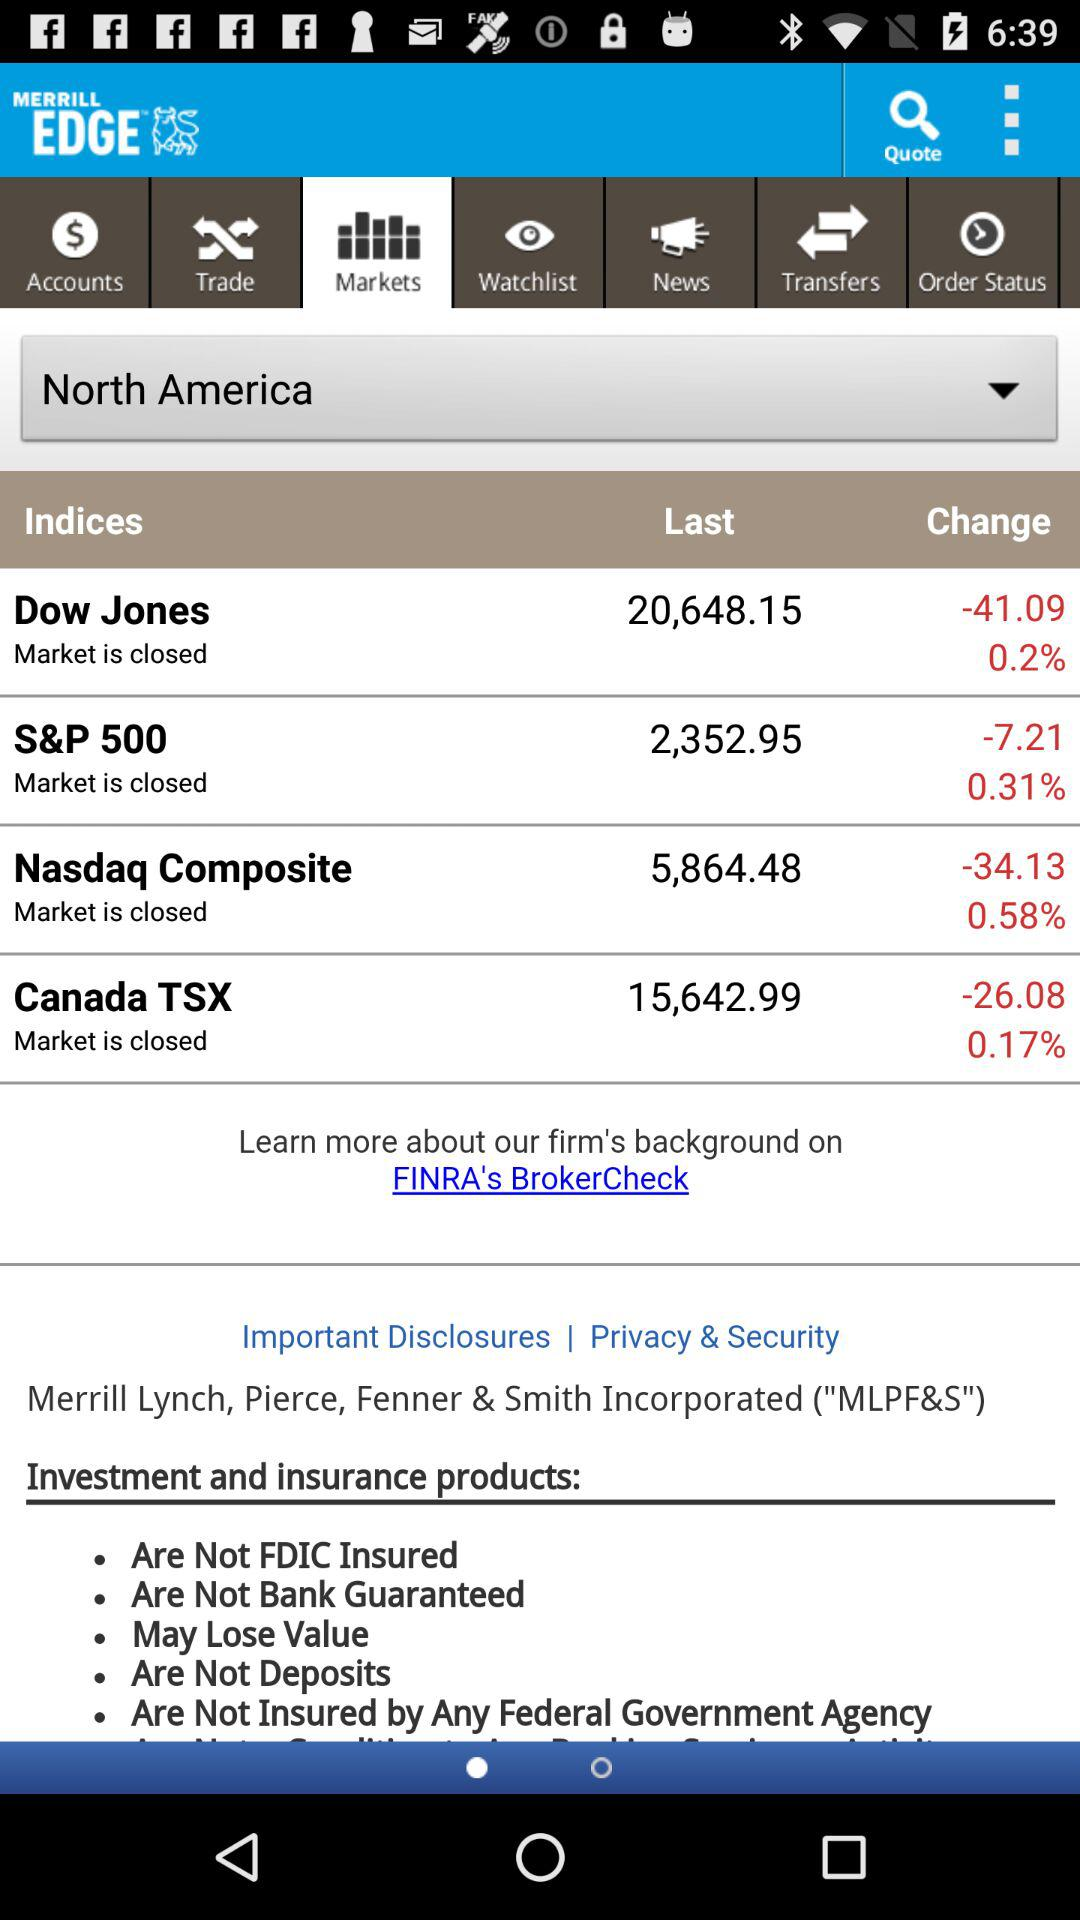How many dollars is the Dow Jones down?
Answer the question using a single word or phrase. -41.09 